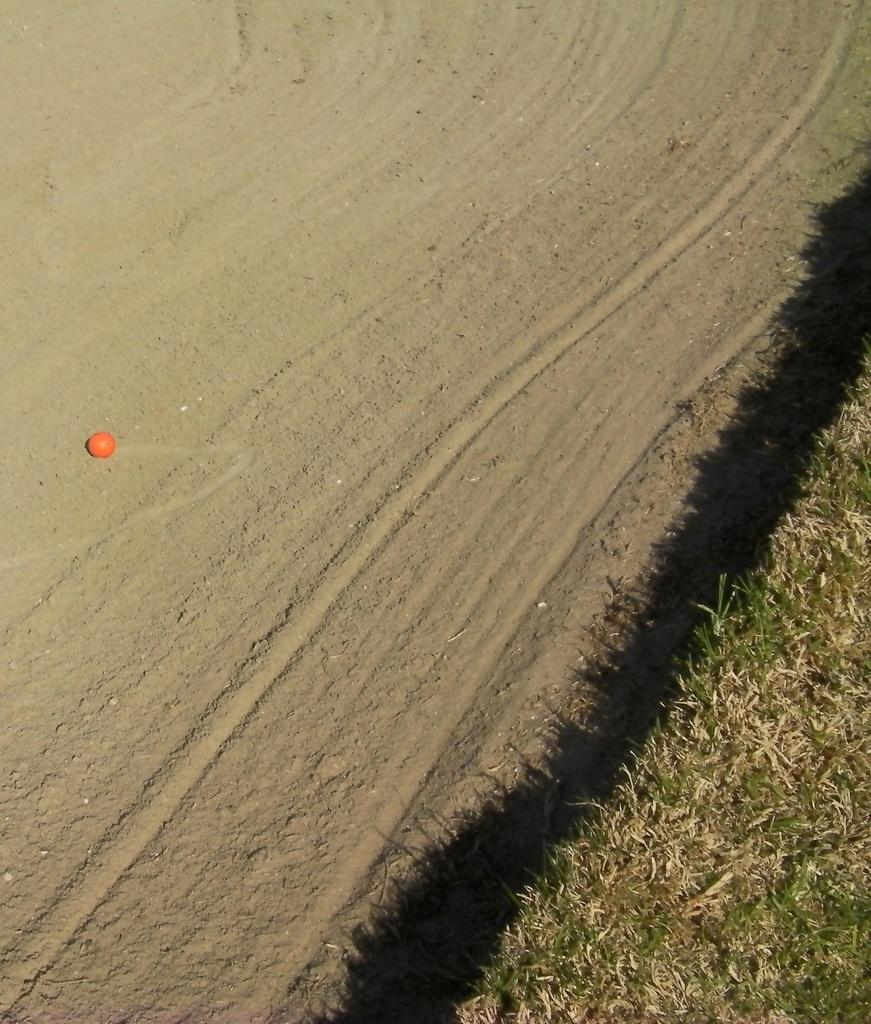What type of terrain is visible in the image? There is a plain ground in the image. What can be seen on the right side of the image? There is a land full of grass on the right side of the image. What type of dock can be seen near the grassy land in the image? There is no dock present in the image; it only features a plain ground and a land full of grass. 